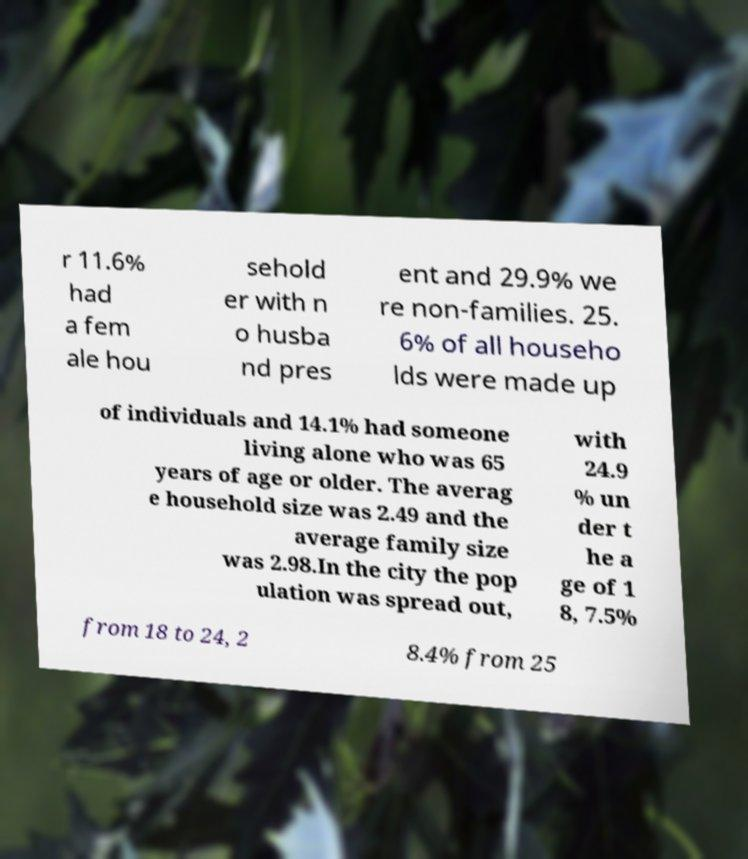Can you read and provide the text displayed in the image?This photo seems to have some interesting text. Can you extract and type it out for me? r 11.6% had a fem ale hou sehold er with n o husba nd pres ent and 29.9% we re non-families. 25. 6% of all househo lds were made up of individuals and 14.1% had someone living alone who was 65 years of age or older. The averag e household size was 2.49 and the average family size was 2.98.In the city the pop ulation was spread out, with 24.9 % un der t he a ge of 1 8, 7.5% from 18 to 24, 2 8.4% from 25 